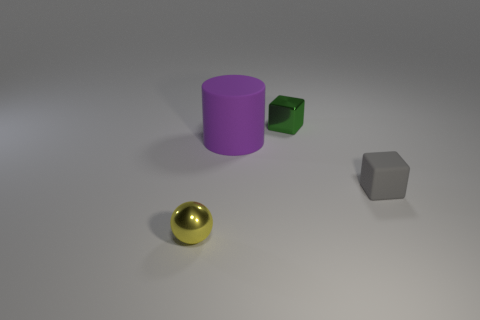The metal sphere that is the same size as the gray object is what color?
Provide a short and direct response. Yellow. What is the color of the shiny thing behind the block on the right side of the metal object that is on the right side of the tiny yellow sphere?
Offer a very short reply. Green. There is a yellow sphere; does it have the same size as the shiny object behind the yellow metal ball?
Make the answer very short. Yes. How many things are purple matte things or small metallic things?
Keep it short and to the point. 3. Are there any gray things made of the same material as the big purple thing?
Ensure brevity in your answer.  Yes. What is the color of the block that is in front of the tiny shiny thing that is behind the tiny yellow shiny sphere?
Offer a very short reply. Gray. Is the size of the yellow ball the same as the metallic cube?
Your response must be concise. Yes. What number of cylinders are either tiny matte things or large rubber things?
Your response must be concise. 1. There is a small metallic object that is behind the metallic sphere; what number of objects are in front of it?
Your answer should be compact. 3. Does the tiny green shiny thing have the same shape as the small gray object?
Provide a succinct answer. Yes. 